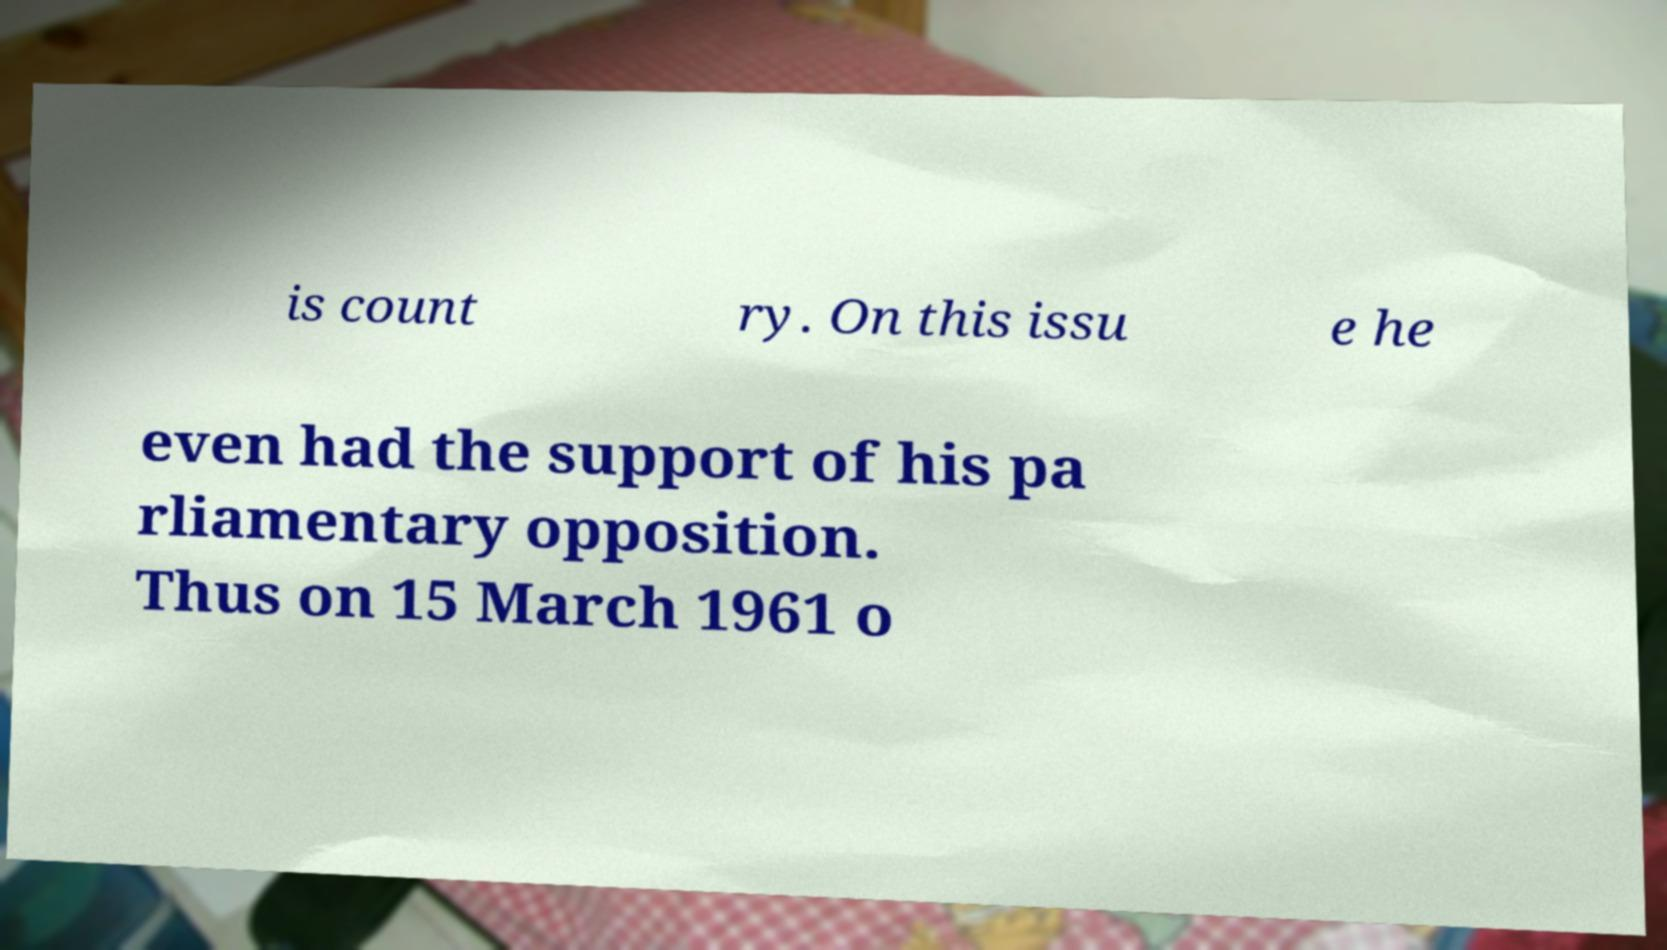Please read and relay the text visible in this image. What does it say? is count ry. On this issu e he even had the support of his pa rliamentary opposition. Thus on 15 March 1961 o 